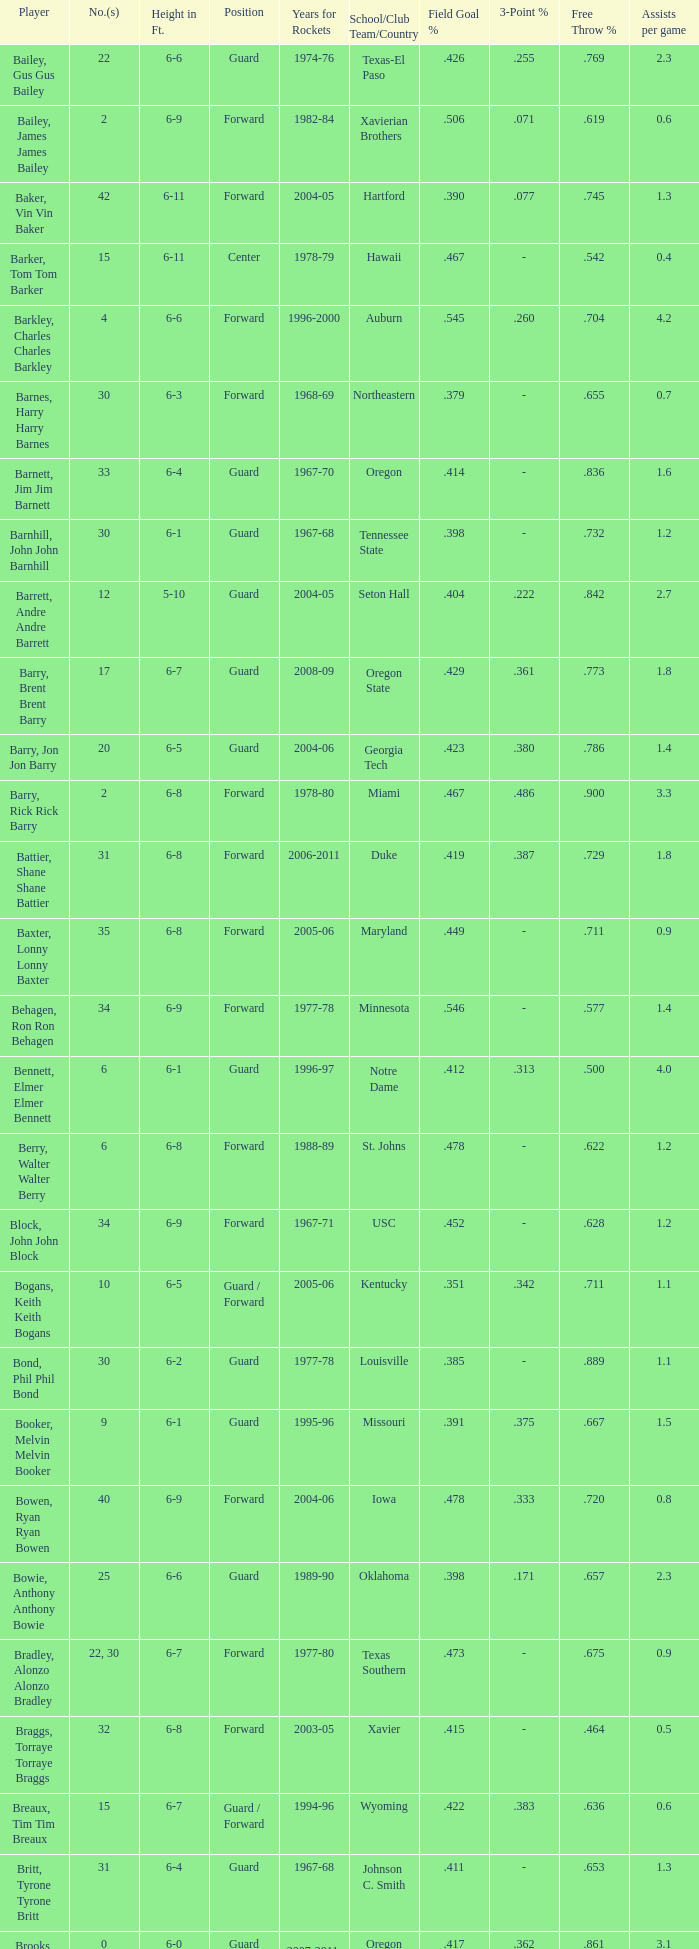What is the height of the player who attended Hartford? 6-11. 